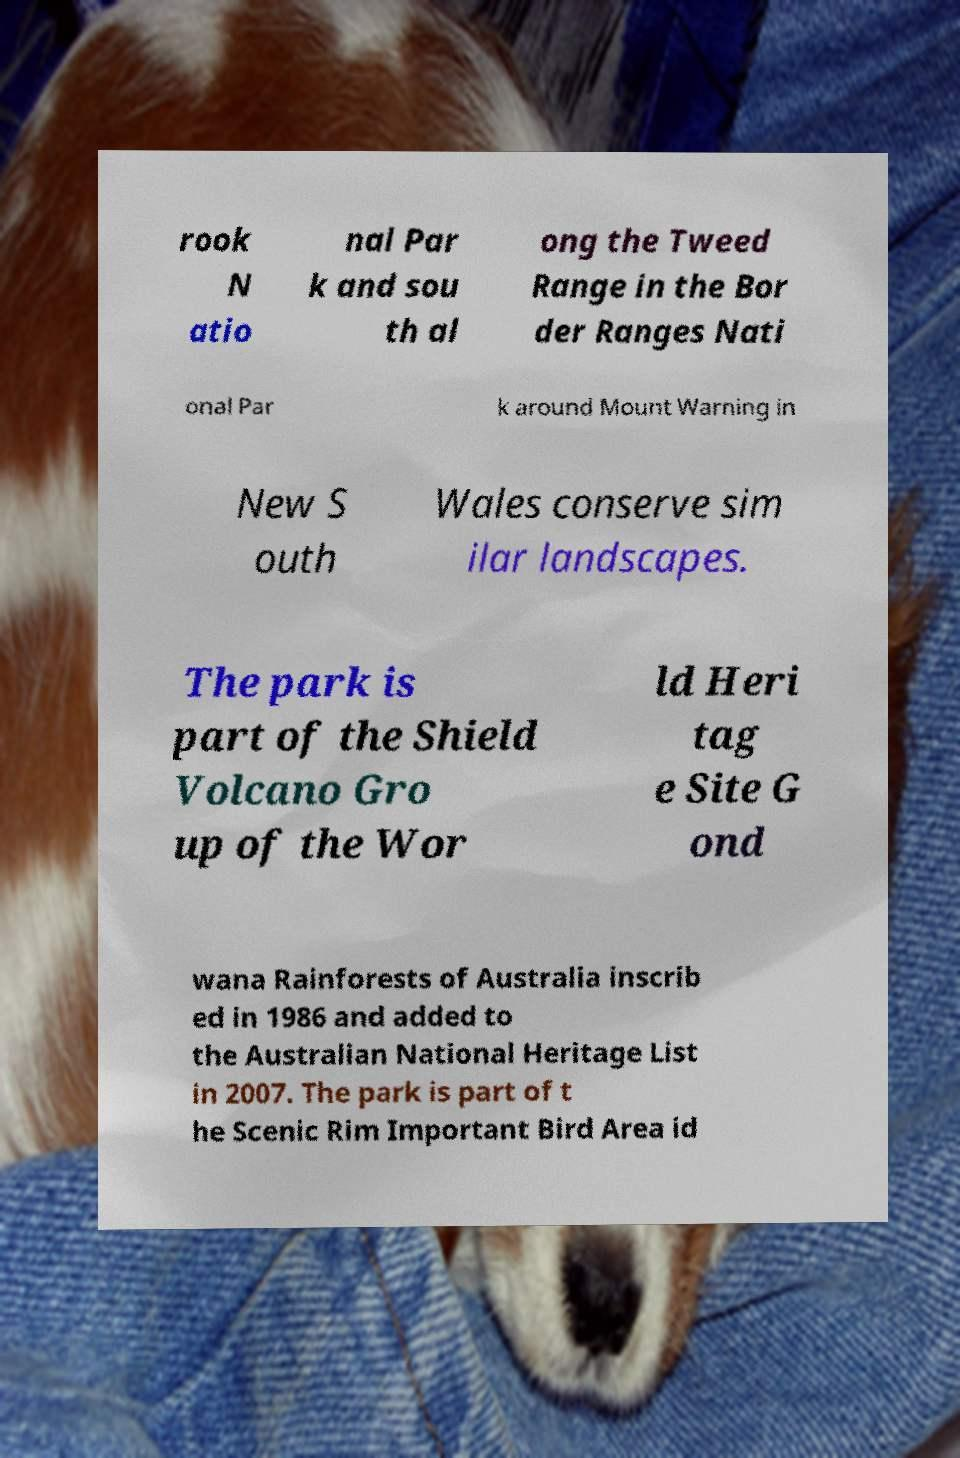Could you assist in decoding the text presented in this image and type it out clearly? rook N atio nal Par k and sou th al ong the Tweed Range in the Bor der Ranges Nati onal Par k around Mount Warning in New S outh Wales conserve sim ilar landscapes. The park is part of the Shield Volcano Gro up of the Wor ld Heri tag e Site G ond wana Rainforests of Australia inscrib ed in 1986 and added to the Australian National Heritage List in 2007. The park is part of t he Scenic Rim Important Bird Area id 